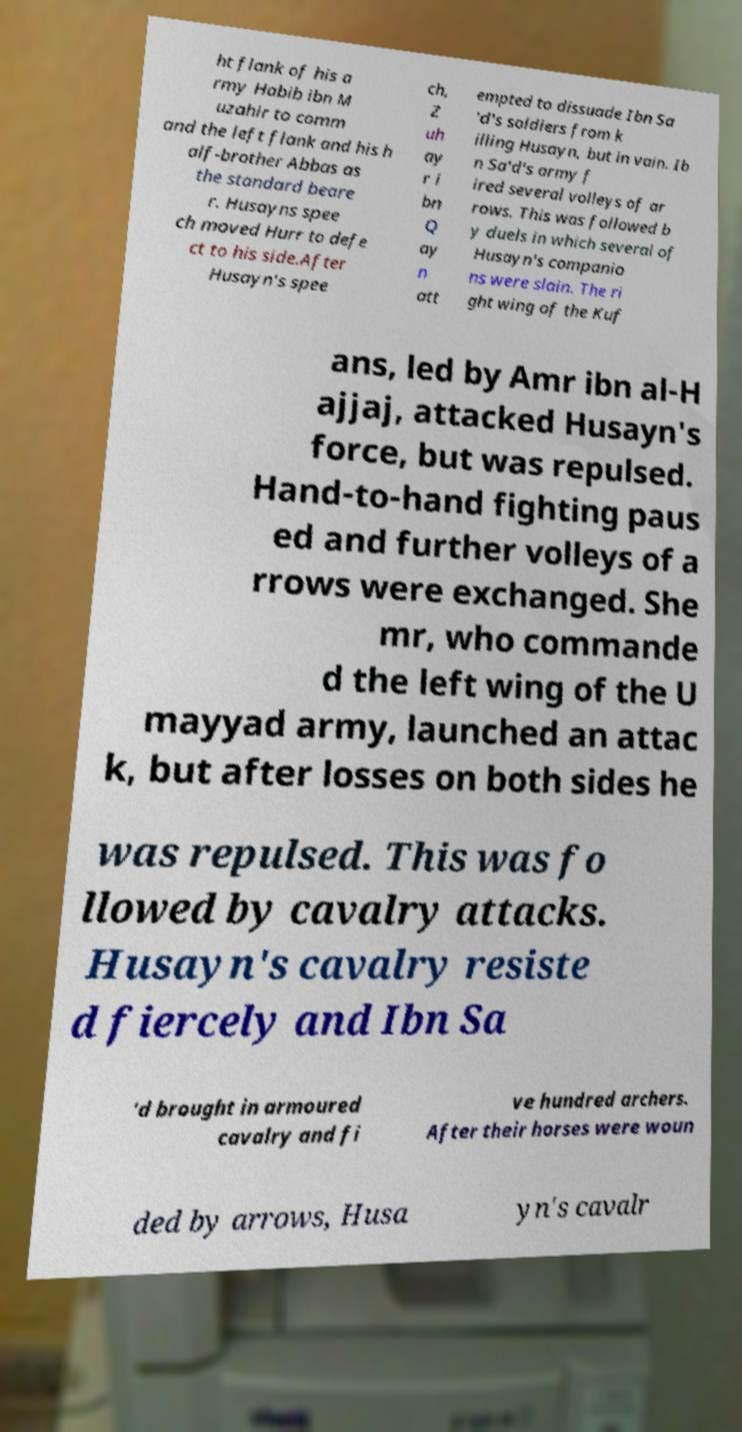For documentation purposes, I need the text within this image transcribed. Could you provide that? ht flank of his a rmy Habib ibn M uzahir to comm and the left flank and his h alf-brother Abbas as the standard beare r. Husayns spee ch moved Hurr to defe ct to his side.After Husayn's spee ch, Z uh ay r i bn Q ay n att empted to dissuade Ibn Sa 'd's soldiers from k illing Husayn, but in vain. Ib n Sa'd's army f ired several volleys of ar rows. This was followed b y duels in which several of Husayn's companio ns were slain. The ri ght wing of the Kuf ans, led by Amr ibn al-H ajjaj, attacked Husayn's force, but was repulsed. Hand-to-hand fighting paus ed and further volleys of a rrows were exchanged. She mr, who commande d the left wing of the U mayyad army, launched an attac k, but after losses on both sides he was repulsed. This was fo llowed by cavalry attacks. Husayn's cavalry resiste d fiercely and Ibn Sa 'd brought in armoured cavalry and fi ve hundred archers. After their horses were woun ded by arrows, Husa yn's cavalr 